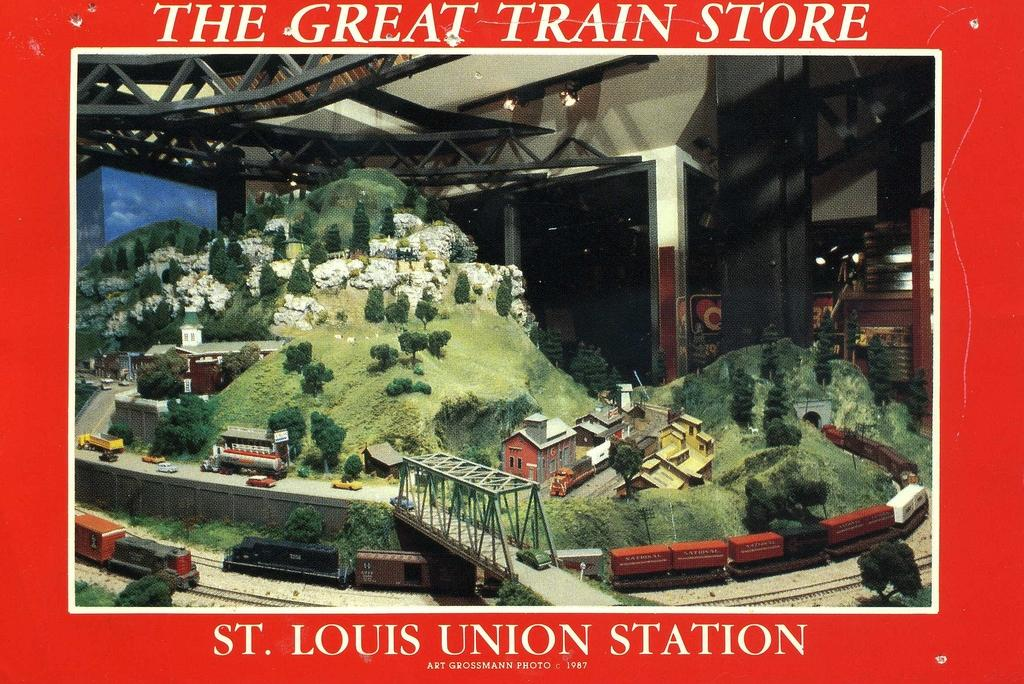What is depicted on the poster in the image? The poster contains a train, a bridge, truss, plants, houses, and hills. Can you describe the setting of the poster? The poster depicts a train passing over a bridge, with truss, plants, houses, and hills in the background. Are there any other elements in the poster besides the ones mentioned? Yes, there are other unspecified elements in the poster. What type of mitten is being used to hold the train in the poster? There is no mitten present in the poster; it features a train, a bridge, truss, plants, houses, and hills. What is the tendency of the plants to grow in the poster? The image does not provide information about the growth tendency of the plants; it only shows their presence in the poster. 